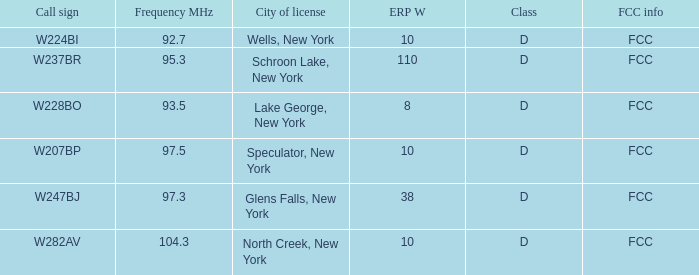Name the FCC info for frequency Mhz less than 97.3 and call sign of w237br FCC. 